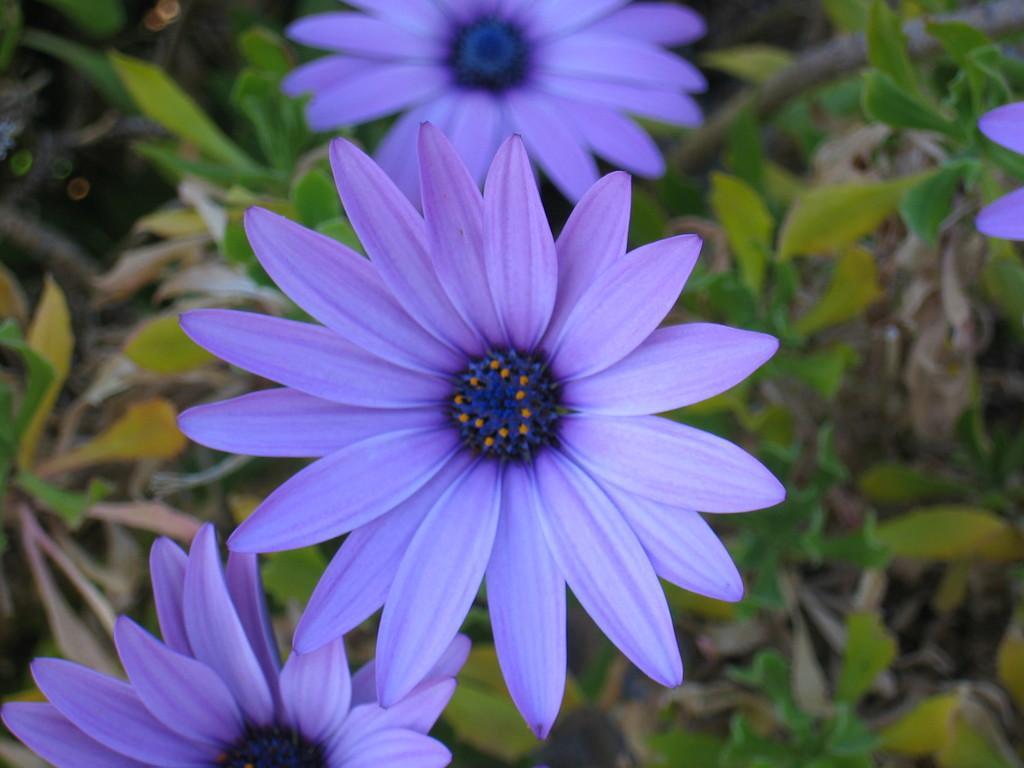Describe this image in one or two sentences. In this image we can see flowers to the plants. 